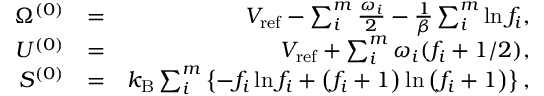Convert formula to latex. <formula><loc_0><loc_0><loc_500><loc_500>\begin{array} { r l r } { \Omega ^ { ( 0 ) } } & { = } & { V _ { r e f } - \sum _ { i } ^ { m } \frac { \omega _ { i } } { 2 } - \frac { 1 } { \beta } \sum _ { i } ^ { m } \ln f _ { i } , } \\ { U ^ { ( 0 ) } } & { = } & { V _ { r e f } + \sum _ { i } ^ { m } \omega _ { i } ( f _ { i } + 1 / 2 ) , } \\ { S ^ { ( 0 ) } } & { = } & { k _ { B } \sum _ { i } ^ { m } \left \{ - f _ { i } \ln f _ { i } + \left ( f _ { i } + 1 \right ) \ln \left ( f _ { i } + 1 \right ) \right \} , } \end{array}</formula> 